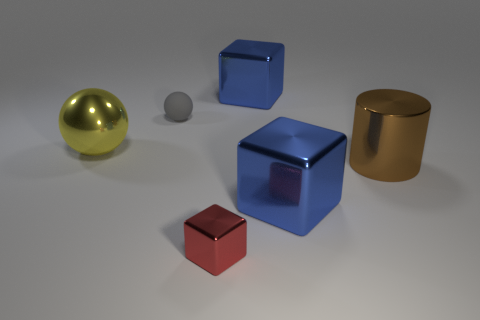Add 2 small cubes. How many objects exist? 8 Subtract all balls. How many objects are left? 4 Add 2 big brown things. How many big brown things are left? 3 Add 5 green blocks. How many green blocks exist? 5 Subtract 0 brown balls. How many objects are left? 6 Subtract all small red metal blocks. Subtract all large green rubber objects. How many objects are left? 5 